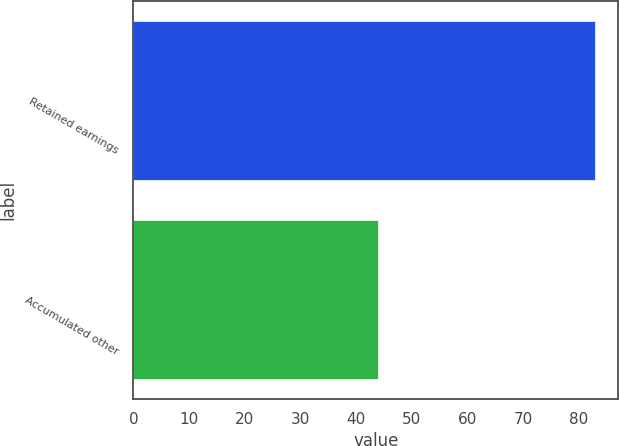Convert chart. <chart><loc_0><loc_0><loc_500><loc_500><bar_chart><fcel>Retained earnings<fcel>Accumulated other<nl><fcel>83<fcel>44<nl></chart> 